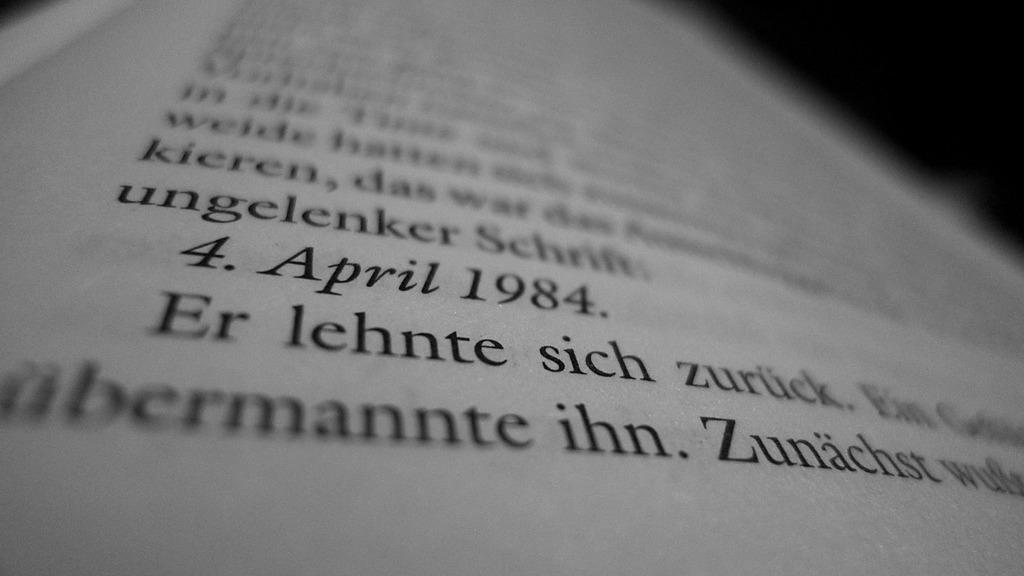<image>
Present a compact description of the photo's key features. A partial page from a book is shown with the date 4. April 1984 printed in it. 